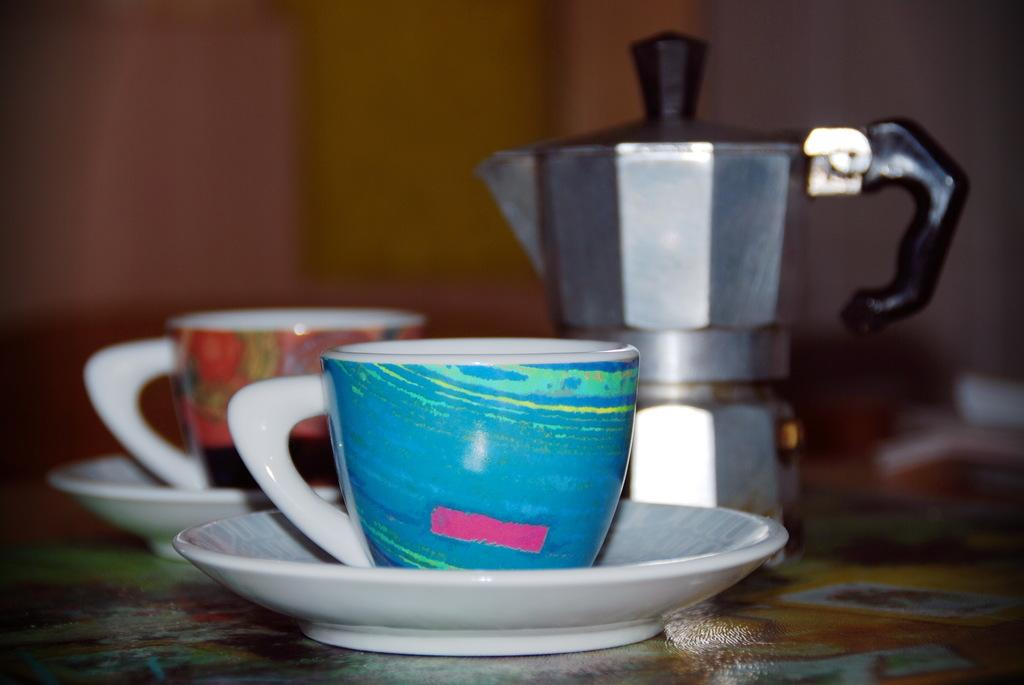What objects are on the table in the image? There are two cups with saucers and a flask on the table. How many cups with saucers are present in the image? There are two cups with saucers in the image. What might be the purpose of the flask on the table? The flask on the table might be used for holding a beverage or liquid. What type of library can be seen in the background of the image? There is no library present in the image; it only features cups with saucers and a flask on a table. What subject is being taught in the image? There is no teaching or lesson being depicted in the image; it only shows cups with saucers and a flask on a table. 